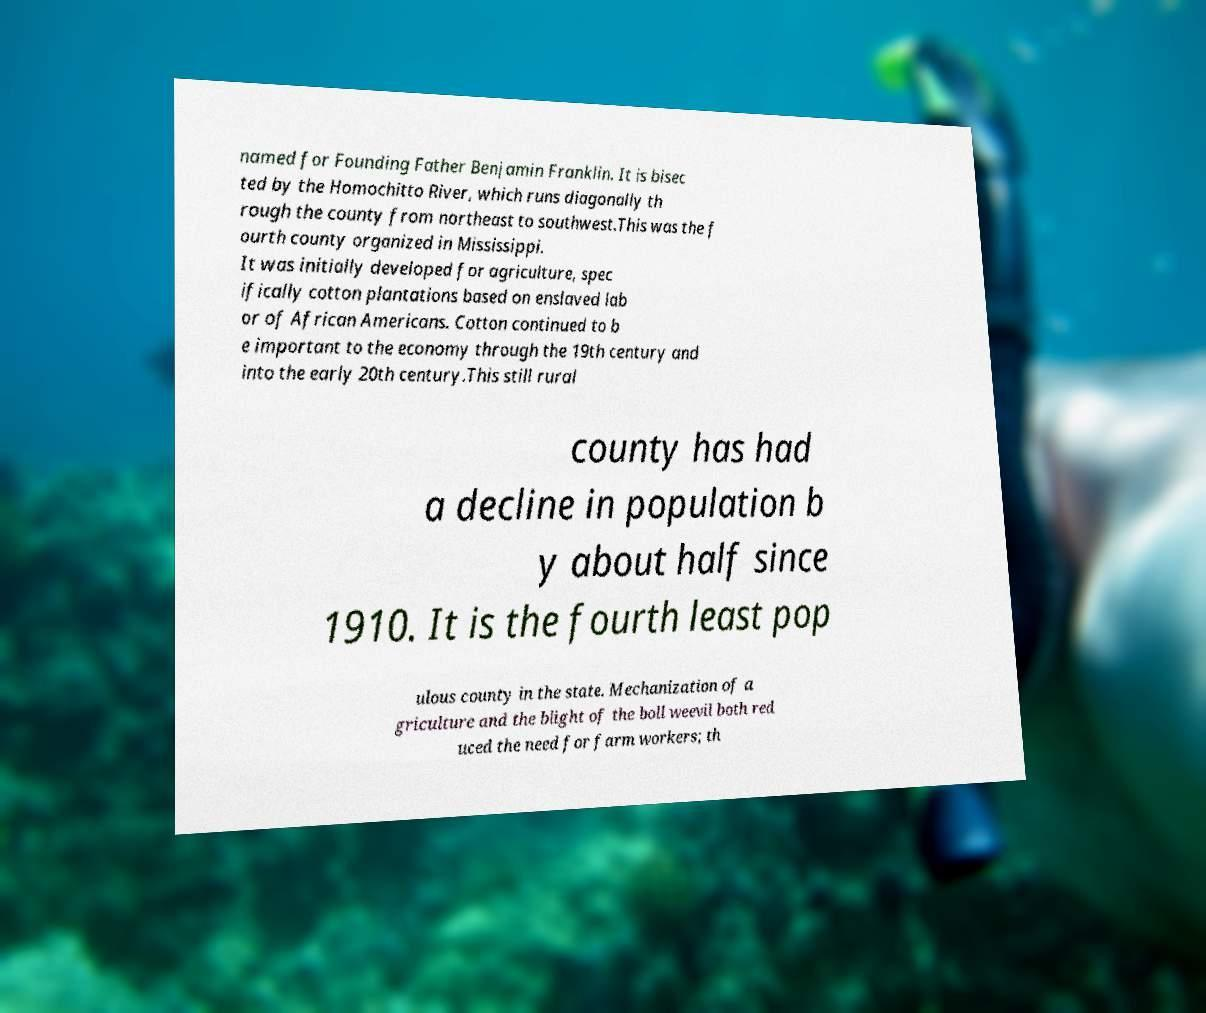Please identify and transcribe the text found in this image. named for Founding Father Benjamin Franklin. It is bisec ted by the Homochitto River, which runs diagonally th rough the county from northeast to southwest.This was the f ourth county organized in Mississippi. It was initially developed for agriculture, spec ifically cotton plantations based on enslaved lab or of African Americans. Cotton continued to b e important to the economy through the 19th century and into the early 20th century.This still rural county has had a decline in population b y about half since 1910. It is the fourth least pop ulous county in the state. Mechanization of a griculture and the blight of the boll weevil both red uced the need for farm workers; th 